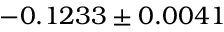Convert formula to latex. <formula><loc_0><loc_0><loc_500><loc_500>- 0 . 1 2 3 3 \pm 0 . 0 0 4 1</formula> 